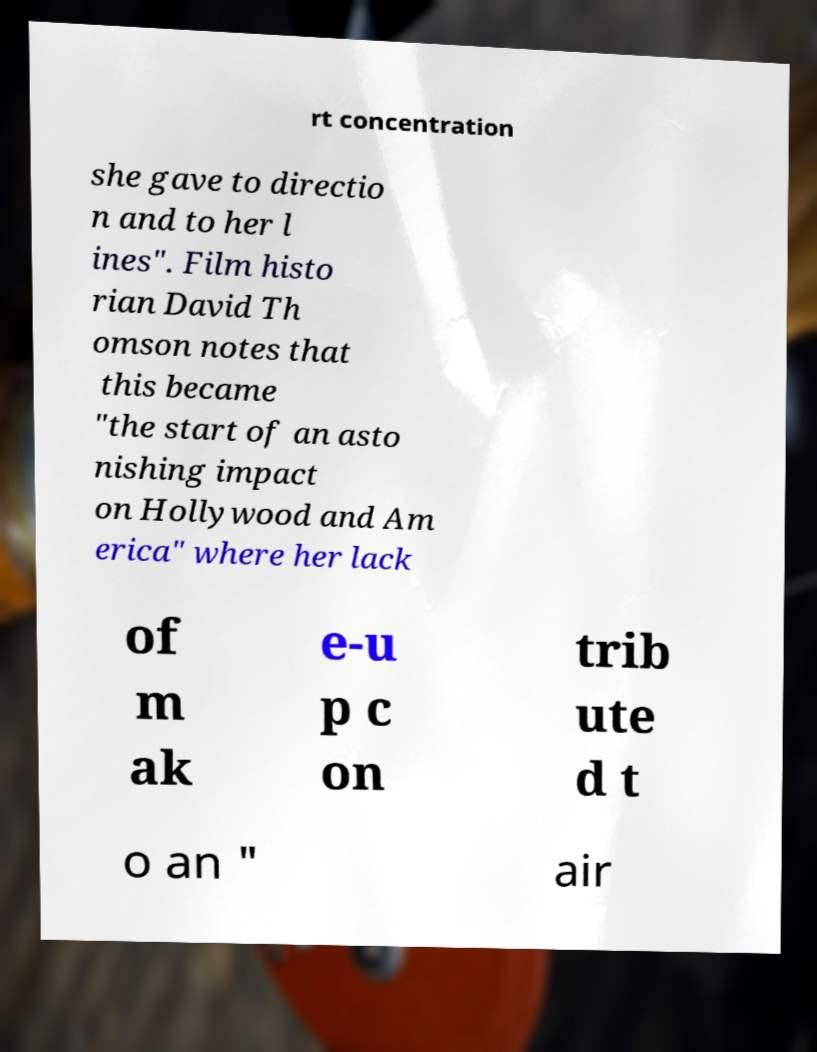Could you assist in decoding the text presented in this image and type it out clearly? rt concentration she gave to directio n and to her l ines". Film histo rian David Th omson notes that this became "the start of an asto nishing impact on Hollywood and Am erica" where her lack of m ak e-u p c on trib ute d t o an " air 